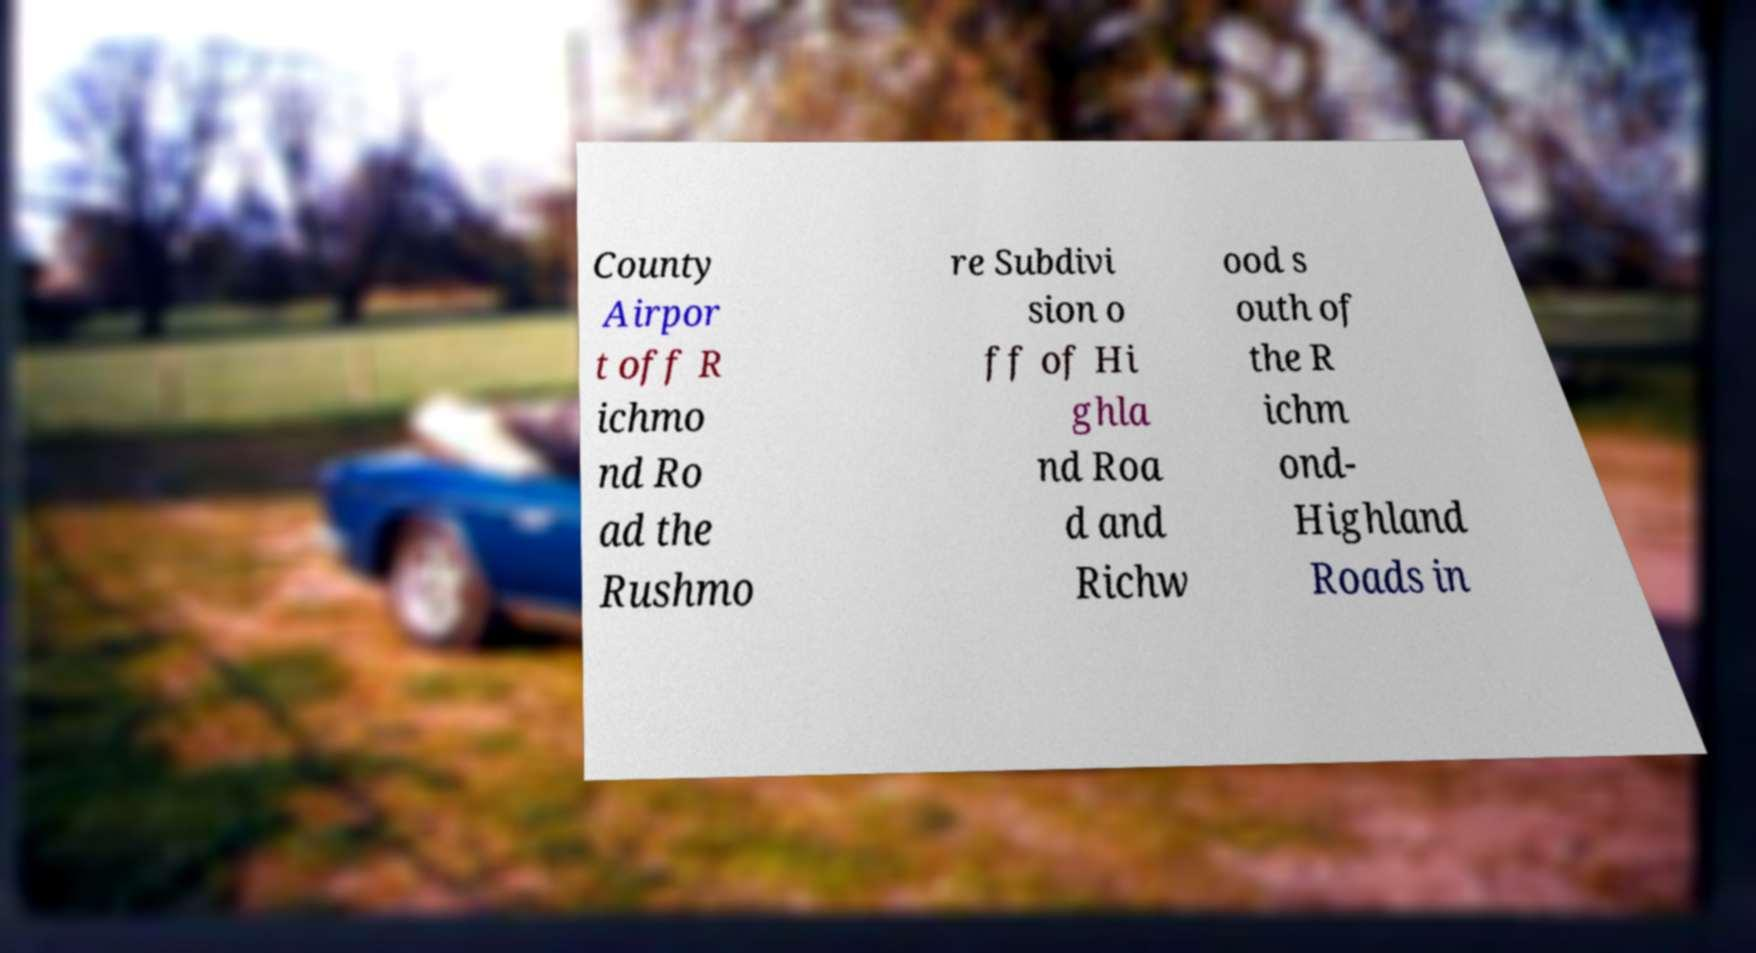I need the written content from this picture converted into text. Can you do that? County Airpor t off R ichmo nd Ro ad the Rushmo re Subdivi sion o ff of Hi ghla nd Roa d and Richw ood s outh of the R ichm ond- Highland Roads in 